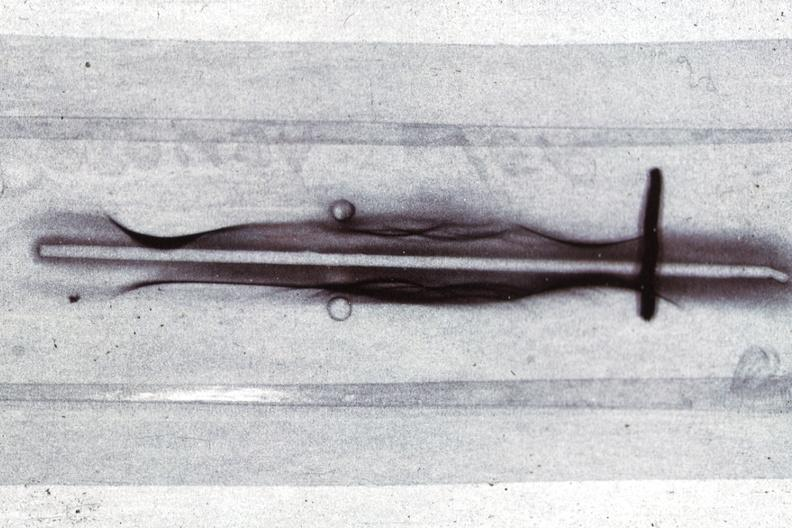what is present?
Answer the question using a single word or phrase. Hematologic 